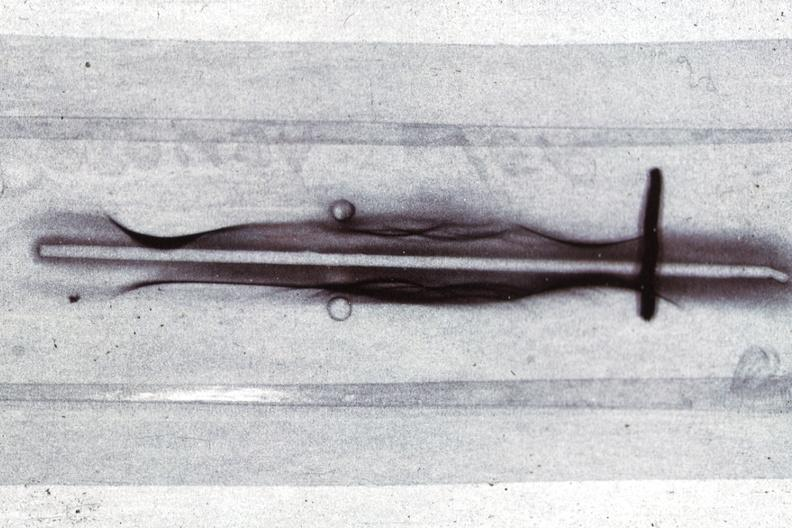what is present?
Answer the question using a single word or phrase. Hematologic 